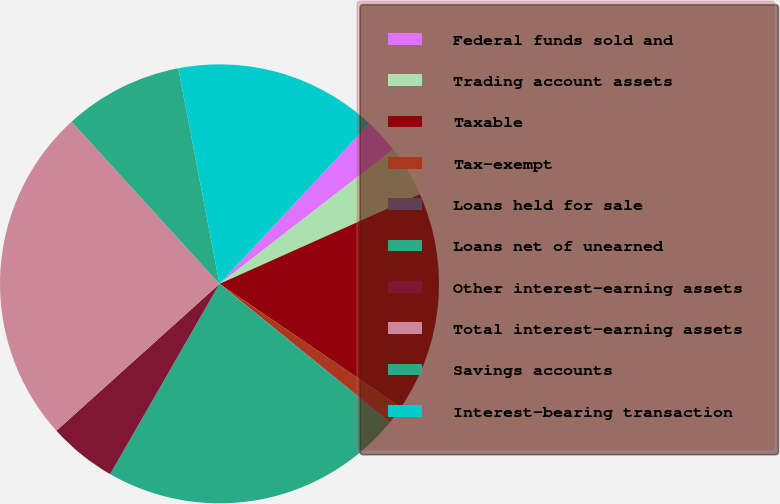Convert chart to OTSL. <chart><loc_0><loc_0><loc_500><loc_500><pie_chart><fcel>Federal funds sold and<fcel>Trading account assets<fcel>Taxable<fcel>Tax-exempt<fcel>Loans held for sale<fcel>Loans net of unearned<fcel>Other interest-earning assets<fcel>Total interest-earning assets<fcel>Savings accounts<fcel>Interest-bearing transaction<nl><fcel>2.55%<fcel>3.79%<fcel>16.21%<fcel>1.31%<fcel>0.07%<fcel>22.41%<fcel>5.03%<fcel>24.9%<fcel>8.76%<fcel>14.97%<nl></chart> 